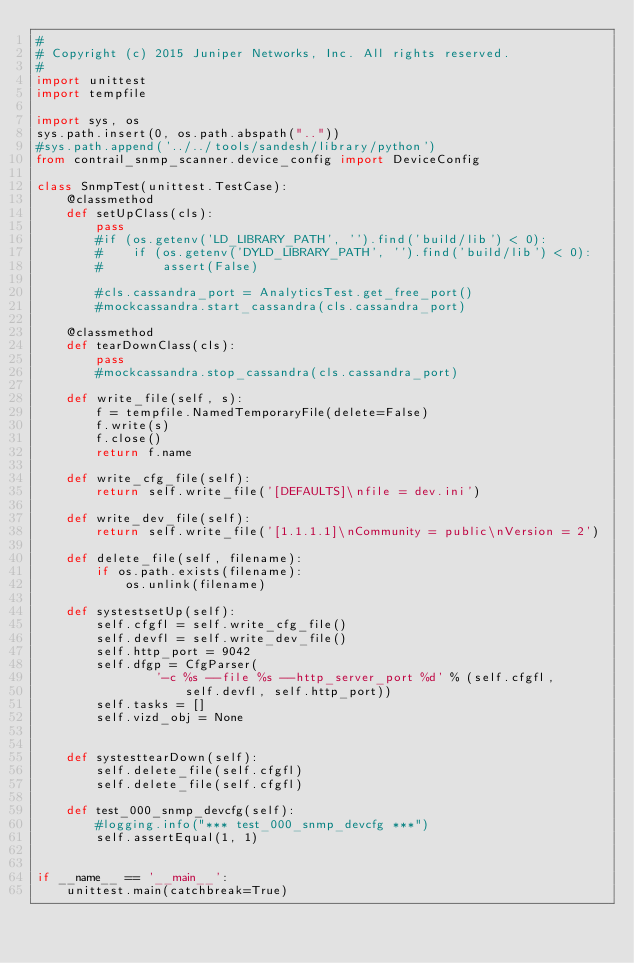<code> <loc_0><loc_0><loc_500><loc_500><_Python_>#
# Copyright (c) 2015 Juniper Networks, Inc. All rights reserved.
#
import unittest
import tempfile

import sys, os
sys.path.insert(0, os.path.abspath(".."))
#sys.path.append('../../tools/sandesh/library/python')
from contrail_snmp_scanner.device_config import DeviceConfig

class SnmpTest(unittest.TestCase):
    @classmethod
    def setUpClass(cls):
        pass
        #if (os.getenv('LD_LIBRARY_PATH', '').find('build/lib') < 0):
        #    if (os.getenv('DYLD_LIBRARY_PATH', '').find('build/lib') < 0):
        #        assert(False)

        #cls.cassandra_port = AnalyticsTest.get_free_port()
        #mockcassandra.start_cassandra(cls.cassandra_port)

    @classmethod
    def tearDownClass(cls):
        pass
        #mockcassandra.stop_cassandra(cls.cassandra_port)

    def write_file(self, s):
        f = tempfile.NamedTemporaryFile(delete=False)
        f.write(s)
        f.close()
        return f.name

    def write_cfg_file(self):
        return self.write_file('[DEFAULTS]\nfile = dev.ini')

    def write_dev_file(self):
        return self.write_file('[1.1.1.1]\nCommunity = public\nVersion = 2')

    def delete_file(self, filename):
        if os.path.exists(filename):
            os.unlink(filename)

    def systestsetUp(self):
        self.cfgfl = self.write_cfg_file()
        self.devfl = self.write_dev_file()
        self.http_port = 9042
        self.dfgp = CfgParser(
                '-c %s --file %s --http_server_port %d' % (self.cfgfl,
                    self.devfl, self.http_port))
        self.tasks = []
        self.vizd_obj = None


    def systesttearDown(self):
        self.delete_file(self.cfgfl)
        self.delete_file(self.cfgfl)

    def test_000_snmp_devcfg(self):
        #logging.info("*** test_000_snmp_devcfg ***")
        self.assertEqual(1, 1)


if __name__ == '__main__':
    unittest.main(catchbreak=True)
</code> 